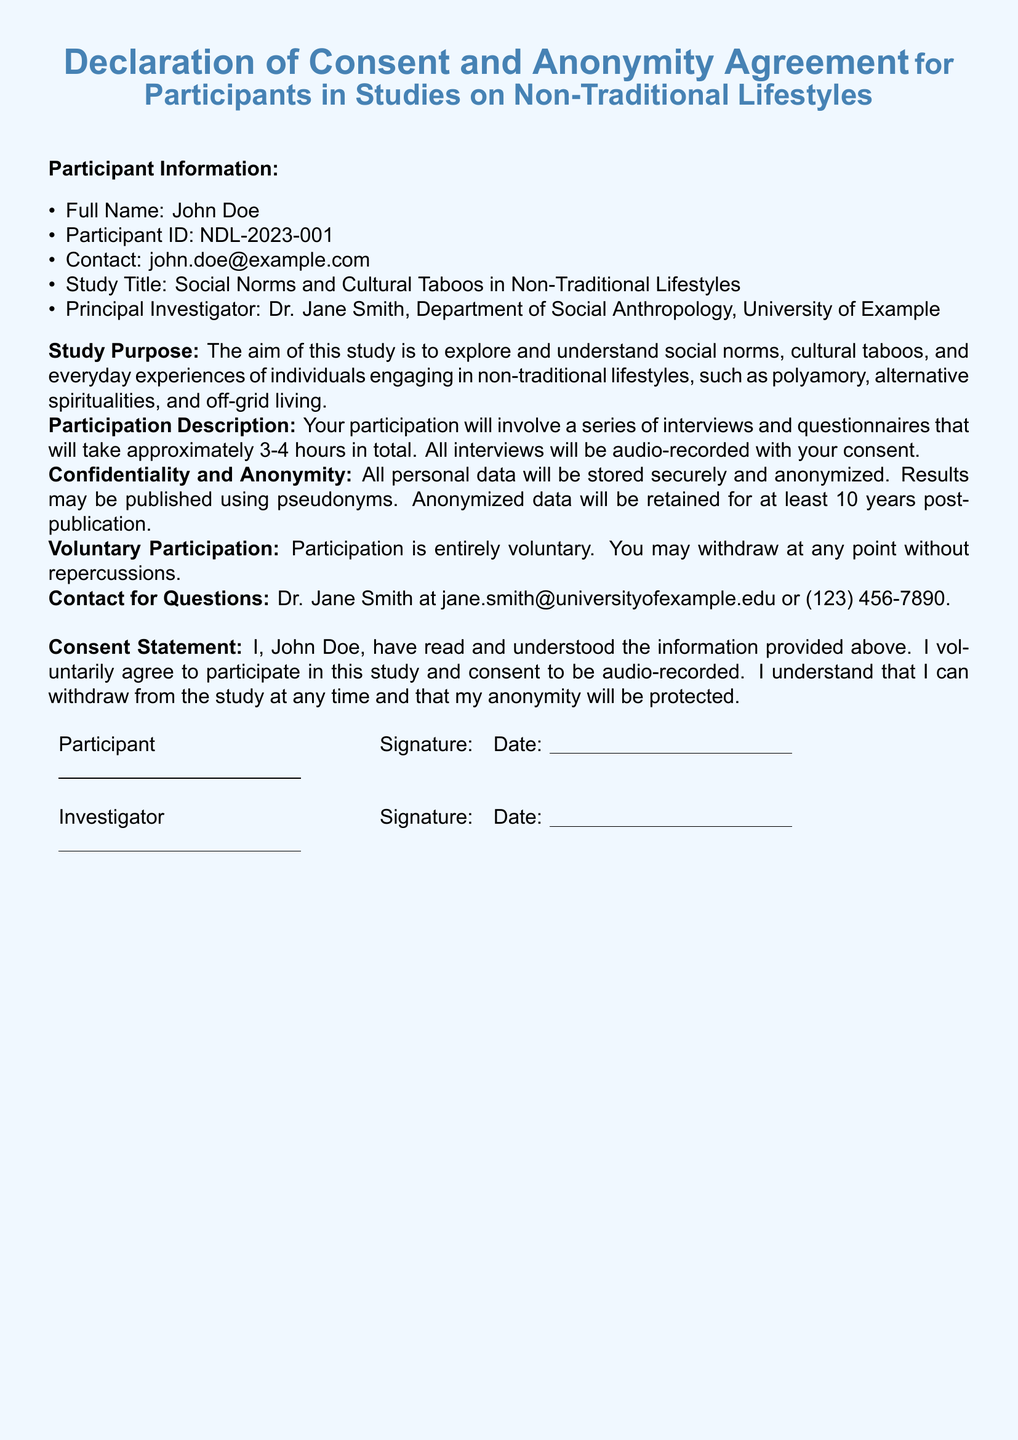What is the participant's full name? The full name of the participant is provided in the document under Participant Information.
Answer: John Doe What is the Participant ID? The Participant ID uniquely identifies the participant in the study and is listed in the document.
Answer: NDL-2023-001 What is the title of the study? The title of the study is stated in the Participant Information section.
Answer: Social Norms and Cultural Taboos in Non-Traditional Lifestyles How long will the participation take? The estimated duration of the participation is mentioned in the Participation Description section.
Answer: 3-4 hours Who is the Principal Investigator? The Principal Investigator's name is mentioned as part of Participant Information.
Answer: Dr. Jane Smith What is the purpose of the study? The purpose of the study, as described in the document, indicates what the research aims to achieve.
Answer: Explore and understand social norms, cultural taboos, and everyday experiences Is participation voluntary? Whether participation is voluntary is stated clearly in the document.
Answer: Yes How will personal data be stored? The method for storing personal data is described under the Confidentiality and Anonymity section.
Answer: Securely and anonymized How can the participant withdraw? The process of withdrawal is explained in the Voluntary Participation section of the document.
Answer: At any point without repercussions 